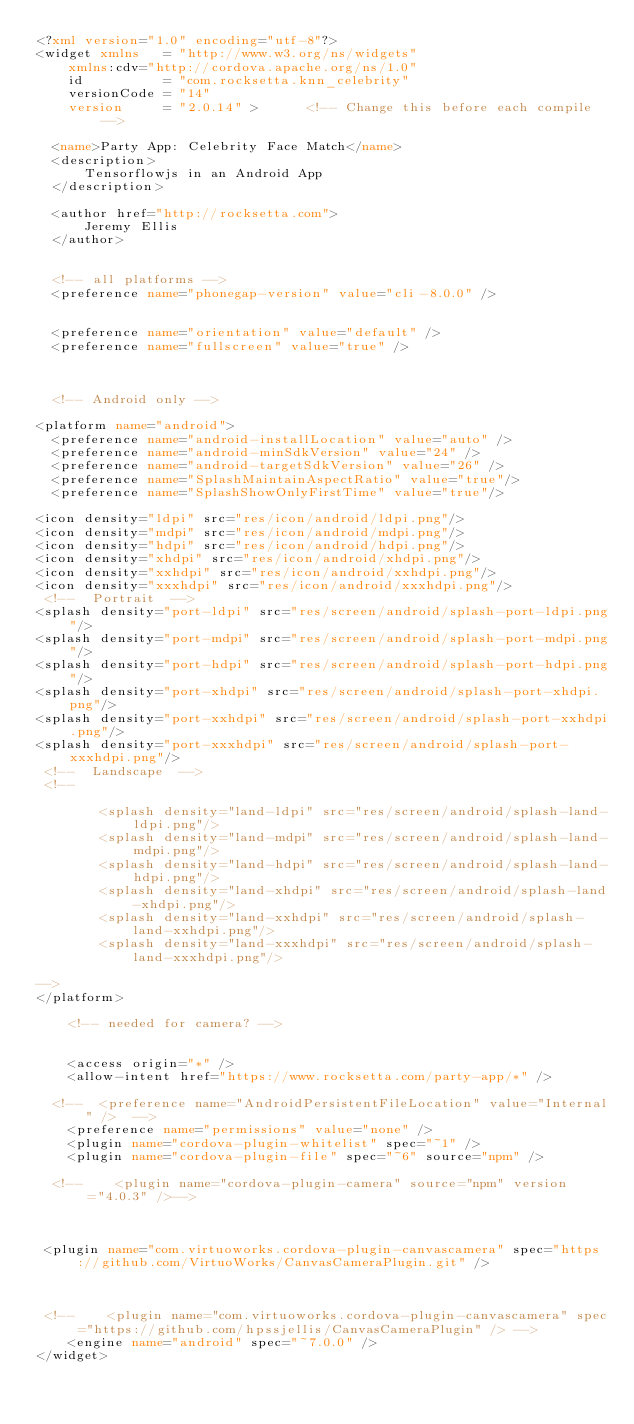<code> <loc_0><loc_0><loc_500><loc_500><_XML_><?xml version="1.0" encoding="utf-8"?>
<widget xmlns   = "http://www.w3.org/ns/widgets"
    xmlns:cdv="http://cordova.apache.org/ns/1.0"
    id          = "com.rocksetta.knn_celebrity"
    versionCode = "14"
    version     = "2.0.14" >      <!-- Change this before each compile -->

  <name>Party App: Celebrity Face Match</name>
  <description>
      Tensorflowjs in an Android App
  </description>
  
  <author href="http://rocksetta.com">
      Jeremy Ellis
  </author>
  
  
  <!-- all platforms -->
  <preference name="phonegap-version" value="cli-8.0.0" />  

 
  <preference name="orientation" value="default" />
  <preference name="fullscreen" value="true" />



  <!-- Android only -->

<platform name="android">
  <preference name="android-installLocation" value="auto" />
  <preference name="android-minSdkVersion" value="24" />
  <preference name="android-targetSdkVersion" value="26" />
  <preference name="SplashMaintainAspectRatio" value="true"/>
  <preference name="SplashShowOnlyFirstTime" value="true"/>
    
<icon density="ldpi" src="res/icon/android/ldpi.png"/>
<icon density="mdpi" src="res/icon/android/mdpi.png"/>
<icon density="hdpi" src="res/icon/android/hdpi.png"/>
<icon density="xhdpi" src="res/icon/android/xhdpi.png"/>
<icon density="xxhdpi" src="res/icon/android/xxhdpi.png"/>
<icon density="xxxhdpi" src="res/icon/android/xxxhdpi.png"/>
 <!--  Portrait  -->
<splash density="port-ldpi" src="res/screen/android/splash-port-ldpi.png"/>
<splash density="port-mdpi" src="res/screen/android/splash-port-mdpi.png"/>
<splash density="port-hdpi" src="res/screen/android/splash-port-hdpi.png"/>
<splash density="port-xhdpi" src="res/screen/android/splash-port-xhdpi.png"/>
<splash density="port-xxhdpi" src="res/screen/android/splash-port-xxhdpi.png"/>
<splash density="port-xxxhdpi" src="res/screen/android/splash-port-xxxhdpi.png"/>
 <!--  Landscape  -->
 <!--

        <splash density="land-ldpi" src="res/screen/android/splash-land-ldpi.png"/>
        <splash density="land-mdpi" src="res/screen/android/splash-land-mdpi.png"/>
        <splash density="land-hdpi" src="res/screen/android/splash-land-hdpi.png"/>
        <splash density="land-xhdpi" src="res/screen/android/splash-land-xhdpi.png"/>
        <splash density="land-xxhdpi" src="res/screen/android/splash-land-xxhdpi.png"/>
        <splash density="land-xxxhdpi" src="res/screen/android/splash-land-xxxhdpi.png"/>
        
-->
</platform>  
    
    <!-- needed for camera? -->  


    <access origin="*" />    
    <allow-intent href="https://www.rocksetta.com/party-app/*" />

  <!--  <preference name="AndroidPersistentFileLocation" value="Internal" />  -->
    <preference name="permissions" value="none" />   
    <plugin name="cordova-plugin-whitelist" spec="~1" /> 
    <plugin name="cordova-plugin-file" spec="~6" source="npm" />  
    
  <!--    <plugin name="cordova-plugin-camera" source="npm" version="4.0.3" />-->
    
 
    
 <plugin name="com.virtuoworks.cordova-plugin-canvascamera" spec="https://github.com/VirtuoWorks/CanvasCameraPlugin.git" />   
    
    
    
 <!--    <plugin name="com.virtuoworks.cordova-plugin-canvascamera" spec="https://github.com/hpssjellis/CanvasCameraPlugin" /> -->
    <engine name="android" spec="~7.0.0" />
</widget>
</code> 